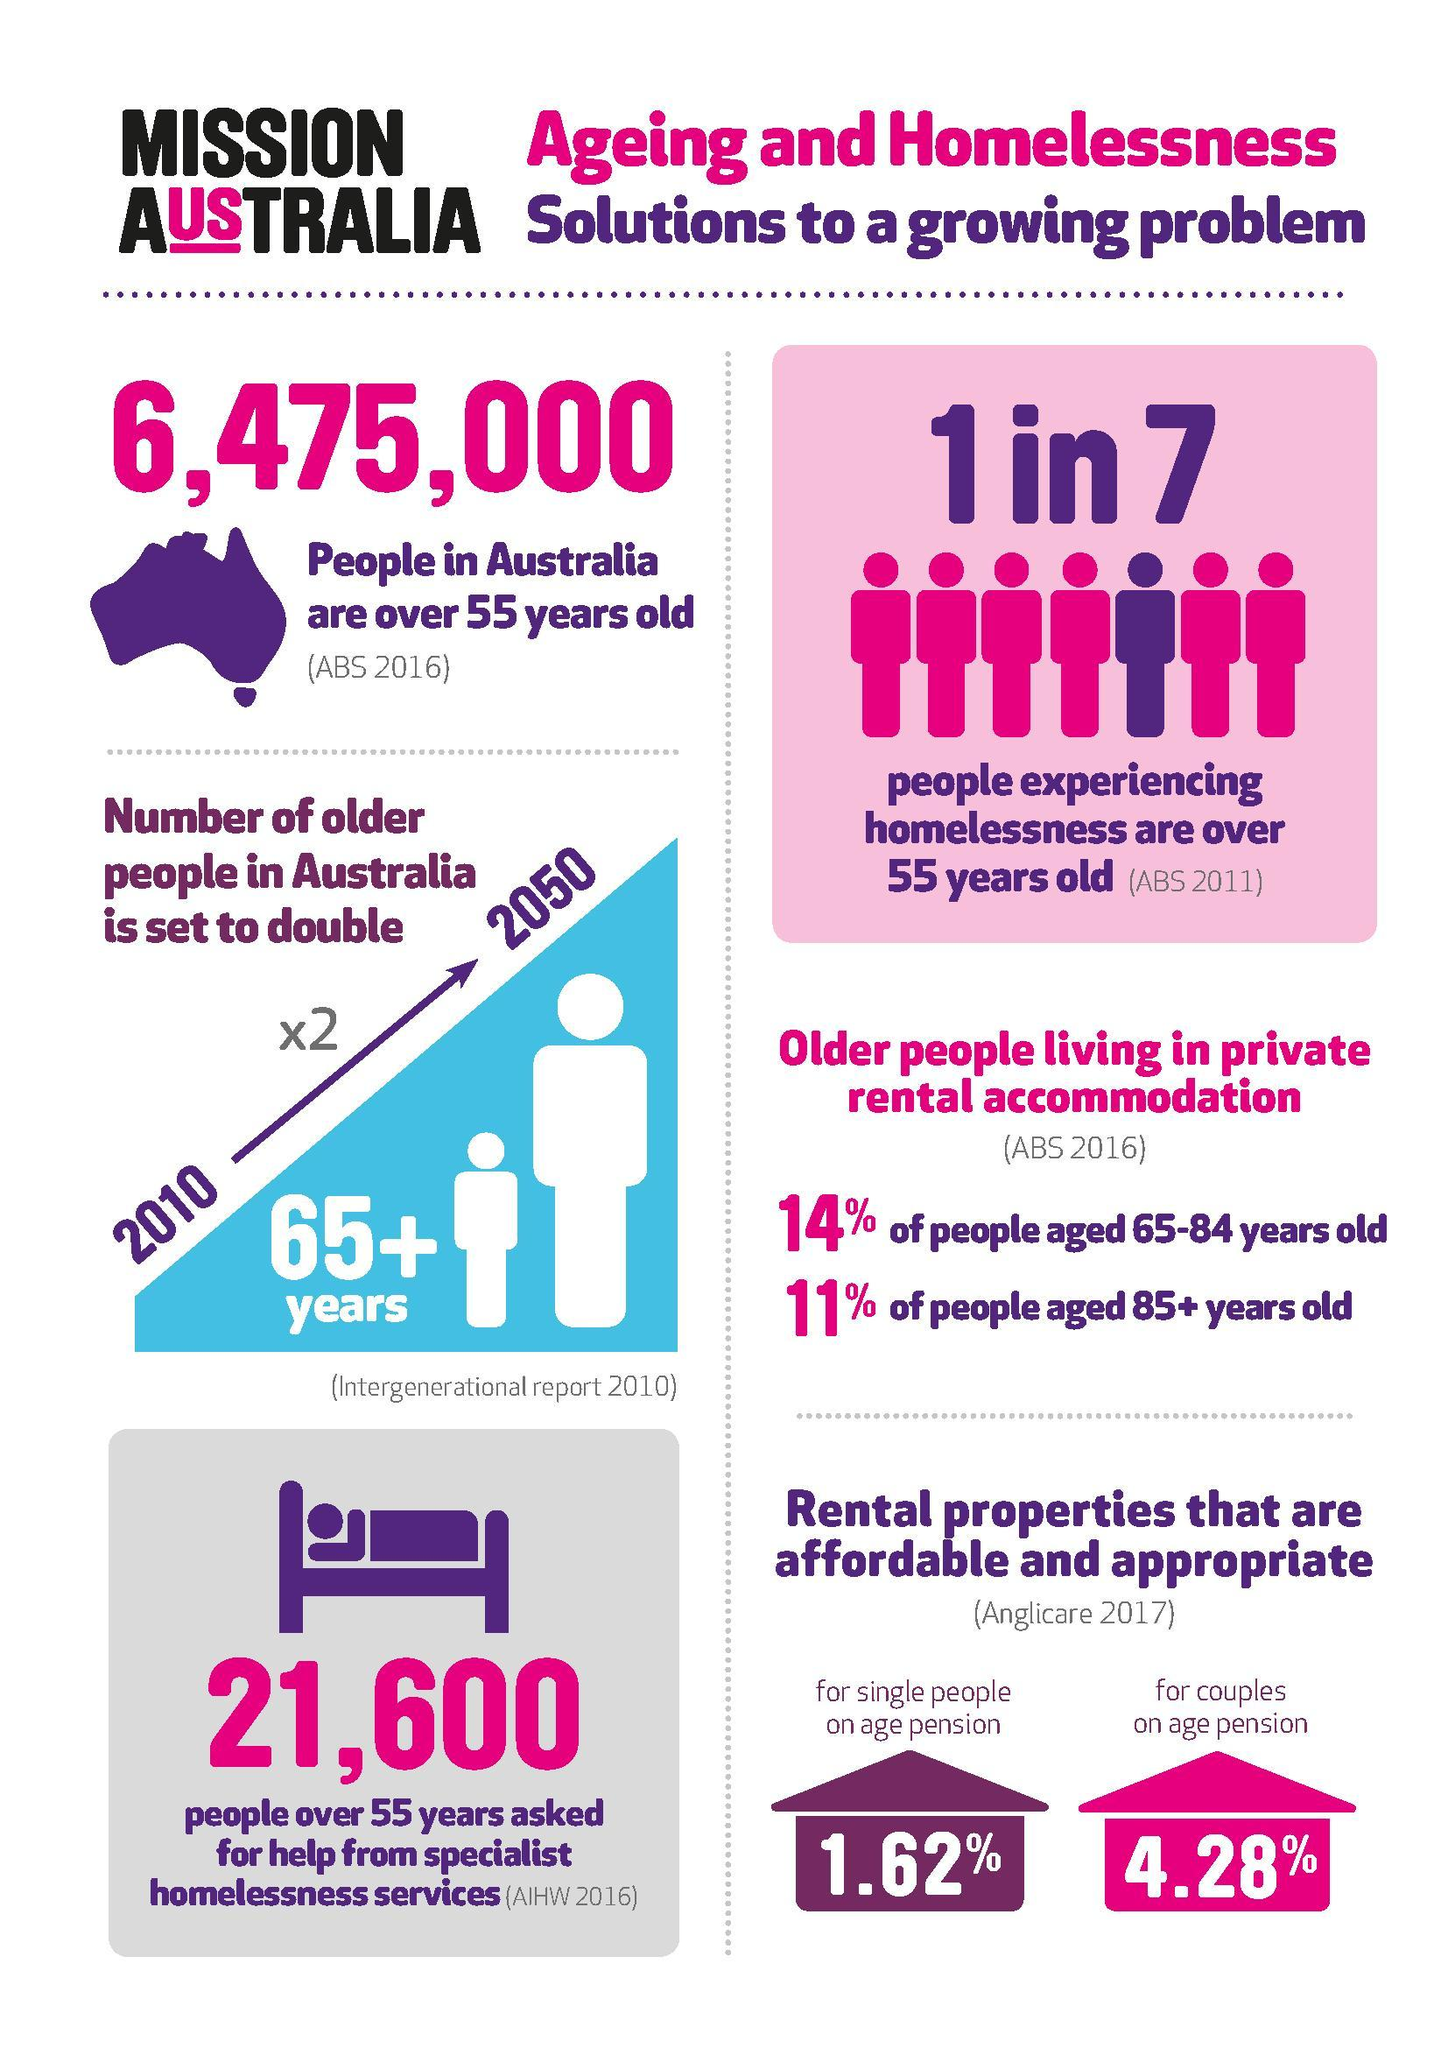According to which survey senior citizens in Australia will be doubled by 2050?
Answer the question with a short phrase. Intergenerational report 2010 1.62% rent rate is allowed for which category of people? for single person on age pension What percent of people aged 65+ and under 85 are not living for rent? 86 What percent of people aged 85+ are not living for rent? 89 According to which survey one in seven Australians are homeless? ABS 2011 What is the age mark for older people? 65+ What is the population of Australia who are aged 55+? 6,475,000 4.28% rent is allowed for which category of people? for couples on age pension The no of senior citizens are set to double in which year? 2050 What percent of Australians aged fifty five plus are homeless? 1 in 7 